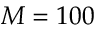Convert formula to latex. <formula><loc_0><loc_0><loc_500><loc_500>M = 1 0 0</formula> 